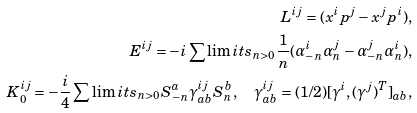<formula> <loc_0><loc_0><loc_500><loc_500>L ^ { i j } = ( x ^ { i } p ^ { j } - x ^ { j } p ^ { i } ) , \\ E ^ { i j } = - i \sum \lim i t s _ { n > 0 } \frac { 1 } { n } ( \alpha _ { - n } ^ { i } \alpha _ { n } ^ { j } - \alpha _ { - n } ^ { j } \alpha _ { n } ^ { i } ) , \\ K _ { 0 } ^ { i j } = - \frac { i } { 4 } \sum \lim i t s _ { n > 0 } S ^ { a } _ { - n } \gamma ^ { i j } _ { a b } S _ { n } ^ { b } , \quad \gamma ^ { i j } _ { a b } = ( 1 / 2 ) [ \gamma ^ { i } , ( \gamma ^ { j } ) ^ { T } ] _ { a b } ,</formula> 